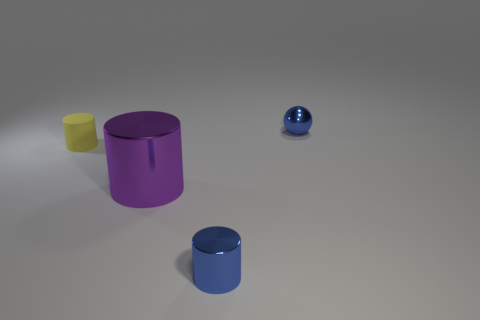Are there any reflective surfaces visible, and if so, what do they reveal about the environment? The purple cylinder and the blue sphere both have reflective surfaces. They reveal a muted reflection of the surroundings, indicating a softly lit room with a homogenous light source, but specific details of the environment are not discernible. 